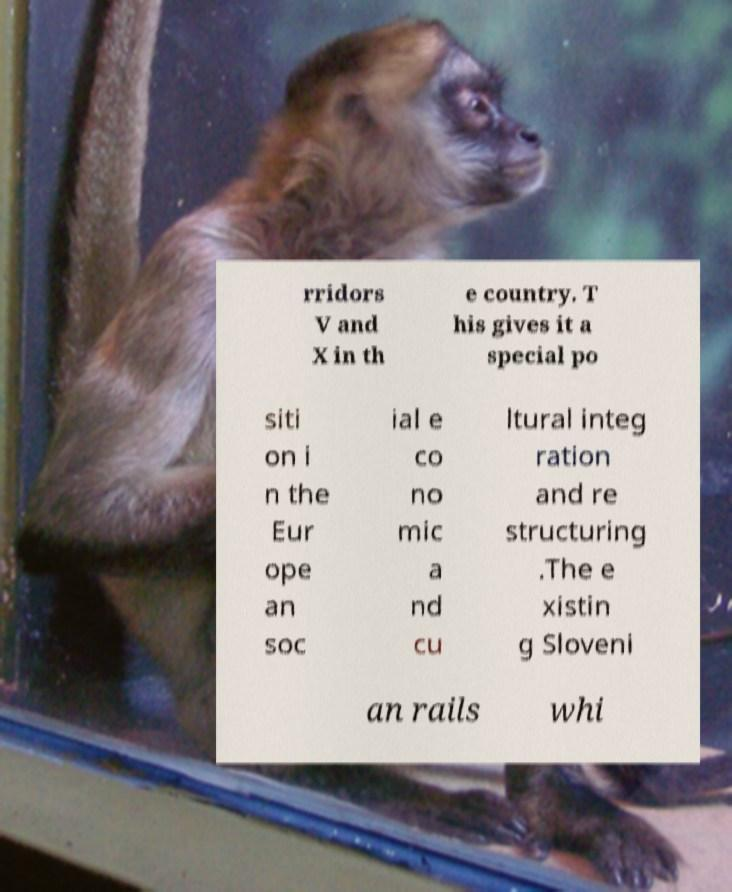For documentation purposes, I need the text within this image transcribed. Could you provide that? rridors V and X in th e country. T his gives it a special po siti on i n the Eur ope an soc ial e co no mic a nd cu ltural integ ration and re structuring .The e xistin g Sloveni an rails whi 